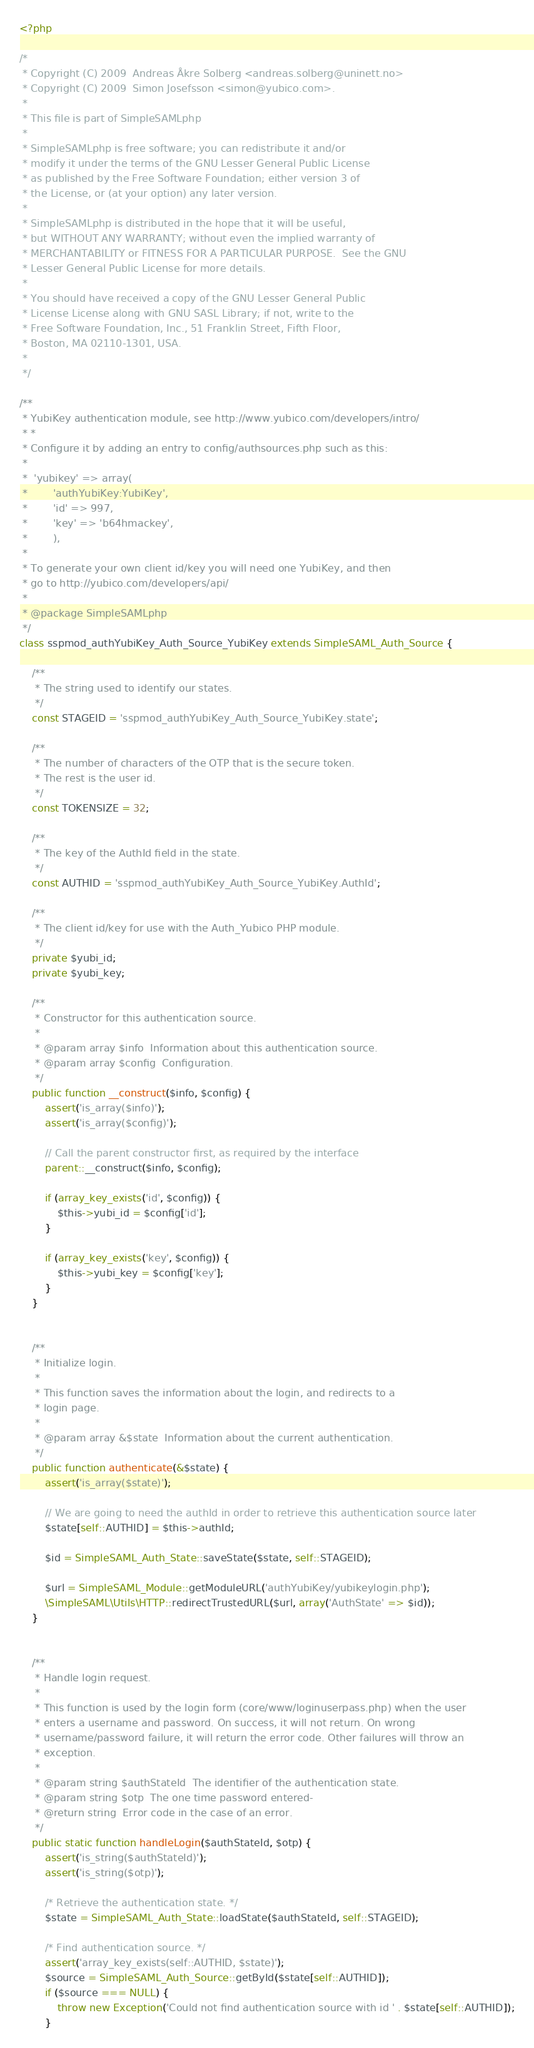Convert code to text. <code><loc_0><loc_0><loc_500><loc_500><_PHP_><?php

/*
 * Copyright (C) 2009  Andreas Åkre Solberg <andreas.solberg@uninett.no>
 * Copyright (C) 2009  Simon Josefsson <simon@yubico.com>.
 *
 * This file is part of SimpleSAMLphp
 *
 * SimpleSAMLphp is free software; you can redistribute it and/or
 * modify it under the terms of the GNU Lesser General Public License
 * as published by the Free Software Foundation; either version 3 of
 * the License, or (at your option) any later version.
 *
 * SimpleSAMLphp is distributed in the hope that it will be useful,
 * but WITHOUT ANY WARRANTY; without even the implied warranty of
 * MERCHANTABILITY or FITNESS FOR A PARTICULAR PURPOSE.  See the GNU
 * Lesser General Public License for more details.
 *
 * You should have received a copy of the GNU Lesser General Public
 * License License along with GNU SASL Library; if not, write to the
 * Free Software Foundation, Inc., 51 Franklin Street, Fifth Floor,
 * Boston, MA 02110-1301, USA.
 *
 */

/**
 * YubiKey authentication module, see http://www.yubico.com/developers/intro/
 * *
 * Configure it by adding an entry to config/authsources.php such as this:
 *
 *	'yubikey' => array(
 *		  'authYubiKey:YubiKey',
 *		  'id' => 997,
 *		  'key' => 'b64hmackey',
 *		  ),
 *
 * To generate your own client id/key you will need one YubiKey, and then
 * go to http://yubico.com/developers/api/
 *
 * @package SimpleSAMLphp
 */
class sspmod_authYubiKey_Auth_Source_YubiKey extends SimpleSAML_Auth_Source {

	/**
	 * The string used to identify our states.
	 */
	const STAGEID = 'sspmod_authYubiKey_Auth_Source_YubiKey.state';

	/**
	 * The number of characters of the OTP that is the secure token.
	 * The rest is the user id.
	 */
	const TOKENSIZE = 32;

	/**
	 * The key of the AuthId field in the state.
	 */
	const AUTHID = 'sspmod_authYubiKey_Auth_Source_YubiKey.AuthId';

	/**
	 * The client id/key for use with the Auth_Yubico PHP module.
	 */
	private $yubi_id;
	private $yubi_key;

	/**
	 * Constructor for this authentication source.
	 *
	 * @param array $info  Information about this authentication source.
	 * @param array $config  Configuration.
	 */
	public function __construct($info, $config) {
		assert('is_array($info)');
		assert('is_array($config)');

		// Call the parent constructor first, as required by the interface
		parent::__construct($info, $config);

		if (array_key_exists('id', $config)) {
			$this->yubi_id = $config['id'];
		}

		if (array_key_exists('key', $config)) {
			$this->yubi_key = $config['key'];
		}
	}


	/**
	 * Initialize login.
	 *
	 * This function saves the information about the login, and redirects to a
	 * login page.
	 *
	 * @param array &$state  Information about the current authentication.
	 */
	public function authenticate(&$state) {
		assert('is_array($state)');

		// We are going to need the authId in order to retrieve this authentication source later
		$state[self::AUTHID] = $this->authId;

		$id = SimpleSAML_Auth_State::saveState($state, self::STAGEID);

		$url = SimpleSAML_Module::getModuleURL('authYubiKey/yubikeylogin.php');
		\SimpleSAML\Utils\HTTP::redirectTrustedURL($url, array('AuthState' => $id));
	}
	
	
	/**
	 * Handle login request.
	 *
	 * This function is used by the login form (core/www/loginuserpass.php) when the user
	 * enters a username and password. On success, it will not return. On wrong
	 * username/password failure, it will return the error code. Other failures will throw an
	 * exception.
	 *
	 * @param string $authStateId  The identifier of the authentication state.
	 * @param string $otp  The one time password entered-
	 * @return string  Error code in the case of an error.
	 */
	public static function handleLogin($authStateId, $otp) {
		assert('is_string($authStateId)');
		assert('is_string($otp)');

		/* Retrieve the authentication state. */
		$state = SimpleSAML_Auth_State::loadState($authStateId, self::STAGEID);

		/* Find authentication source. */
		assert('array_key_exists(self::AUTHID, $state)');
		$source = SimpleSAML_Auth_Source::getById($state[self::AUTHID]);
		if ($source === NULL) {
			throw new Exception('Could not find authentication source with id ' . $state[self::AUTHID]);
		}

</code> 